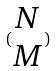<formula> <loc_0><loc_0><loc_500><loc_500>( \begin{matrix} N \\ M \end{matrix} )</formula> 